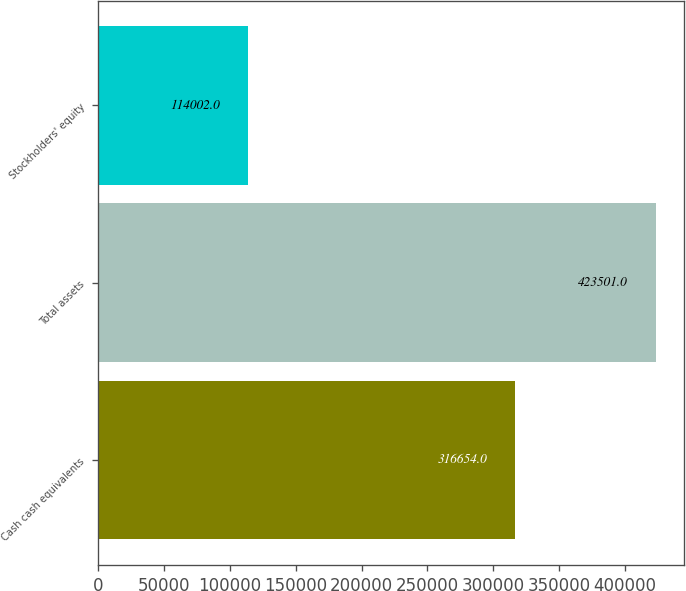<chart> <loc_0><loc_0><loc_500><loc_500><bar_chart><fcel>Cash cash equivalents<fcel>Total assets<fcel>Stockholders' equity<nl><fcel>316654<fcel>423501<fcel>114002<nl></chart> 